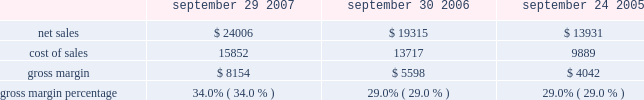Capital asset purchases associated with the retail segment were $ 294 million in 2007 , bringing the total capital asset purchases since inception of the retail segment to $ 1.0 billion .
As of september 29 , 2007 , the retail segment had approximately 7900 employees and had outstanding operating lease commitments associated with retail store space and related facilities of $ 1.1 billion .
The company would incur substantial costs if it were to close multiple retail stores .
Such costs could adversely affect the company 2019s financial condition and operating results .
Other segments the company 2019s other segments , which consists of its asia pacific and filemaker operations , experienced an increase in net sales of $ 406 million , or 30% ( 30 % ) during 2007 compared to 2006 .
This increase related primarily to a 58% ( 58 % ) increase in sales of mac portable products and strong ipod sales in the company 2019s asia pacific region .
During 2006 , net sales in other segments increased 35% ( 35 % ) compared to 2005 primarily due to an increase in sales of ipod and mac portable products .
Strong sales growth was a result of the introduction of the updated ipods featuring video-playing capabilities and the new intel-based mac portable products that translated to a 16% ( 16 % ) increase in mac unit sales during 2006 compared to 2005 .
Gross margin gross margin for each of the last three fiscal years are as follows ( in millions , except gross margin percentages ) : september 29 , september 30 , september 24 , 2007 2006 2005 .
Gross margin percentage of 34.0% ( 34.0 % ) in 2007 increased significantly from 29.0% ( 29.0 % ) in 2006 .
The primary drivers of this increase were more favorable costs on certain commodity components , including nand flash memory and dram memory , higher overall revenue that provided for more leverage on fixed production costs and a higher percentage of revenue from the company 2019s direct sales channels .
The company anticipates that its gross margin and the gross margins of the personal computer , consumer electronics and mobile communication industries will be subject to pressure due to price competition .
The company expects gross margin percentage to decline sequentially in the first quarter of 2008 primarily as a result of the full-quarter impact of product transitions and reduced pricing that were effected in the fourth quarter of 2007 , lower sales of ilife and iwork in their second quarter of availability , seasonally higher component costs , and a higher mix of indirect sales .
These factors are expected to be partially offset by higher sales of the company 2019s mac os x operating system due to the introduction of mac os x version 10.5 leopard ( 2018 2018mac os x leopard 2019 2019 ) that became available in october 2007 .
The foregoing statements regarding the company 2019s expected gross margin percentage are forward-looking .
There can be no assurance that current gross margin percentage will be maintained or targeted gross margin percentage levels will be achieved .
In general , gross margins and margins on individual products will remain under downward pressure due to a variety of factors , including continued industry wide global pricing pressures , increased competition , compressed product life cycles , potential increases in the cost and availability of raw material and outside manufacturing services , and a potential shift in the company 2019s sales mix towards products with lower gross margins .
In response to these competitive pressures , the company expects it will continue to take pricing actions with respect to its products .
Gross margins could also be affected by the company 2019s ability to effectively manage product quality and warranty costs and to stimulate .
What was the percentage sales change from 2006 to 2007? 
Computations: ((24006 - 19315) / 19315)
Answer: 0.24287. 